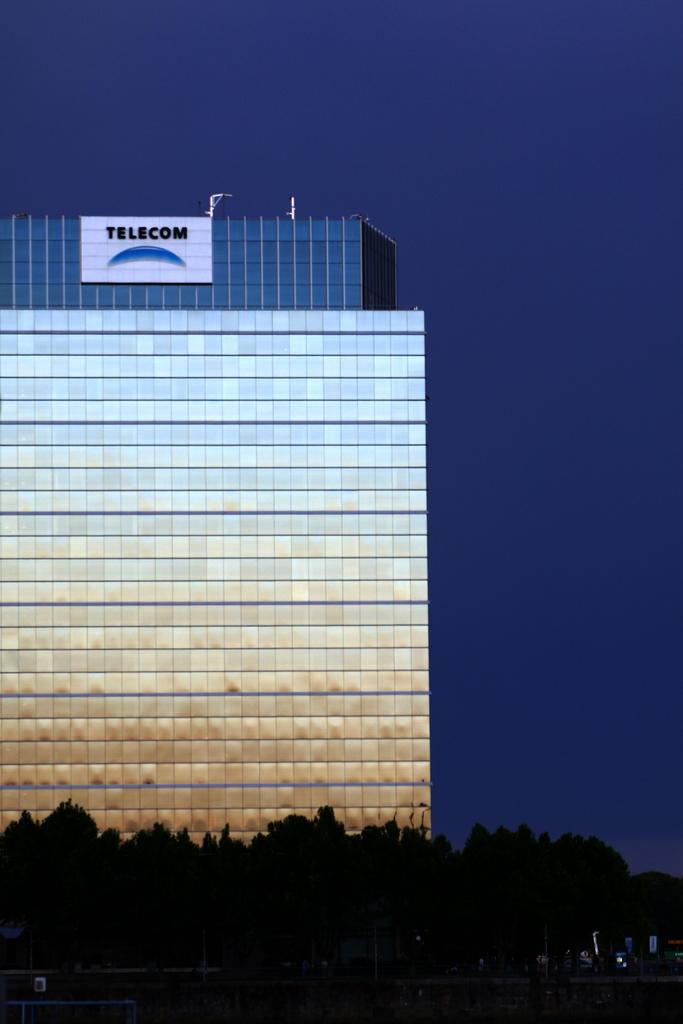What type of structure is visible in the image? There is a building in the image. What other elements can be seen in the image besides the building? There are trees in the image. What type of letter is being delivered by the police in the image? There is no police or letter present in the image; it only features a building and trees. 